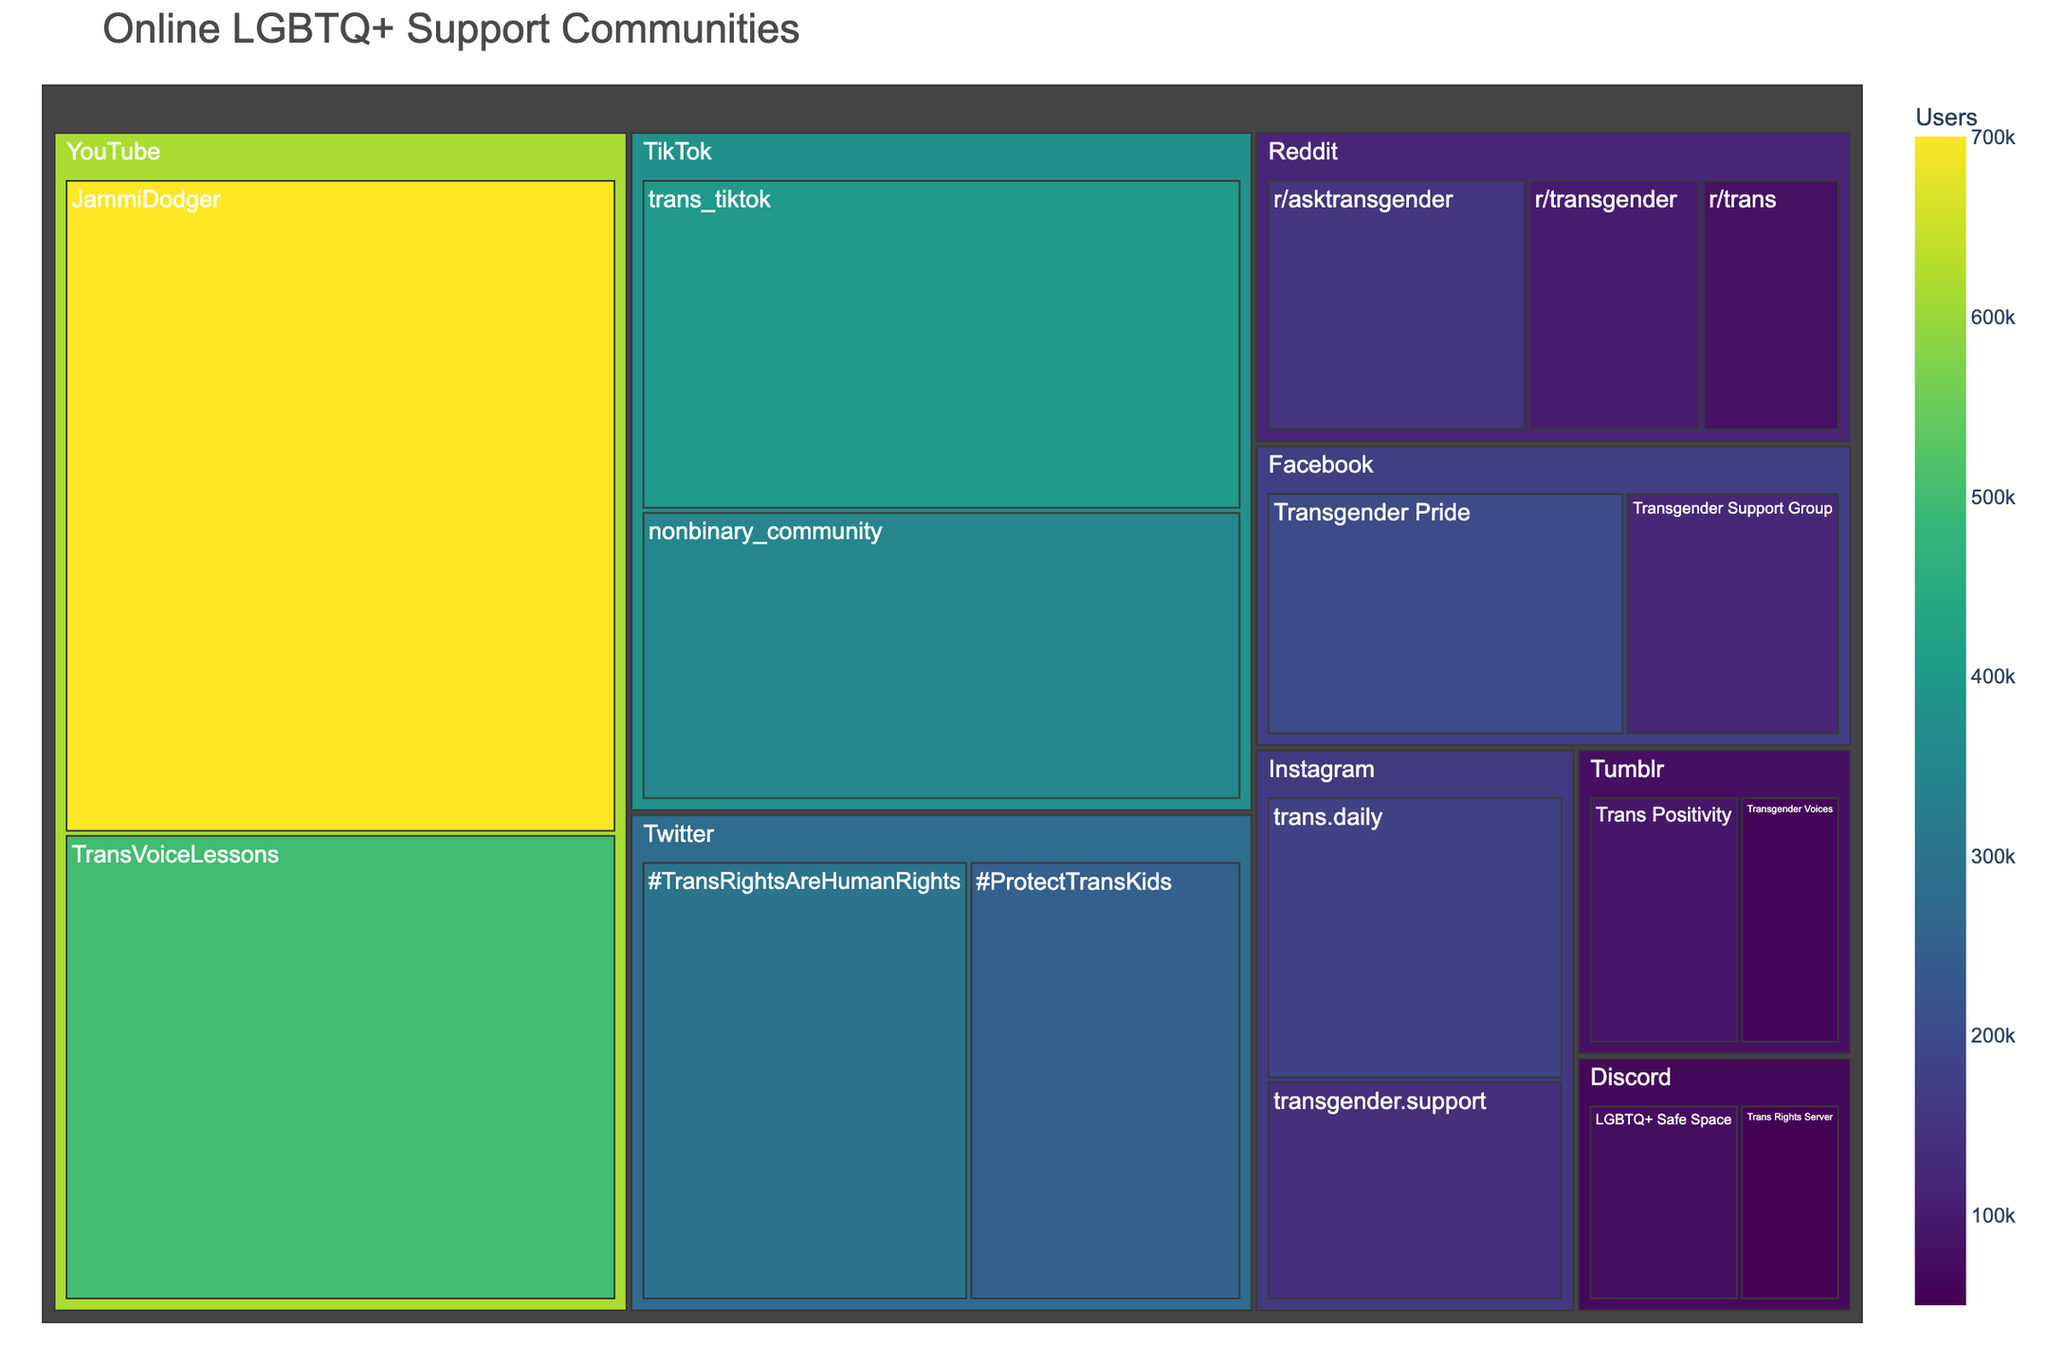What's the platform with the largest number of total users? To determine this, add up the number of users for each community within every platform and then compare the sums. Twitter has #TransRightsAreHumanRights with 300,000 users and #ProtectTransKids with 250,000 users. Summing these gives Twitter a total of 550,000 users, which is the highest amongst the platforms listed.
Answer: Twitter Which community has the most users? Check each community's user count and identify the highest one. YouTube's JammiDodger community has 700,000 users.
Answer: JammiDodger on YouTube Are there more users on Instagram or on Reddit in total? Sum the users for each community under Instagram and Reddit platforms. Instagram communities have a total of 320,000 users (180,000 + 140,000) and Reddit communities have a total of 330,000 users (150,000 + 100,000 + 80,000). Therefore, Reddit has more users.
Answer: Reddit How many users are in the communities specified on Facebook? Add the user counts from Facebook communities: 200,000 (Transgender Pride) + 120,000 (Transgender Support Group) = 320,000.
Answer: 320,000 Which platform has the least number of users? Sum user counts across each platform and identify the smallest total. Discord has 50,000 (Trans Rights Server) + 75,000 (LGBTQ+ Safe Space) = 125,000, which is the smallest total.
Answer: Discord How does the user count for TransVoiceLessons on YouTube compare to the total users on Tumblr? Compare the user count of TransVoiceLessons (500,000) with the sum of the two Tumblr communities: 90,000 (Trans Positivity) + 60,000 (Transgender Voices) = 150,000. TransVoiceLessons has more users than the combined user count of Tumblr communities.
Answer: TransVoiceLessons on YouTube has more users What's the least populated community, and which platform does it belong to? Identify the community with the smallest user count. Trans Rights Server on Discord has the least number of users with 50,000.
Answer: Trans Rights Server on Discord What is the average number of users per community for TikTok? Add user counts for TikTok communities and divide by the number of communities. (400,000 + 350,000) / 2 = 375,000.
Answer: 375,000 